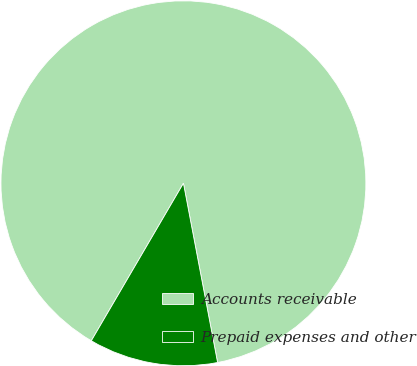<chart> <loc_0><loc_0><loc_500><loc_500><pie_chart><fcel>Accounts receivable<fcel>Prepaid expenses and other<nl><fcel>88.58%<fcel>11.42%<nl></chart> 